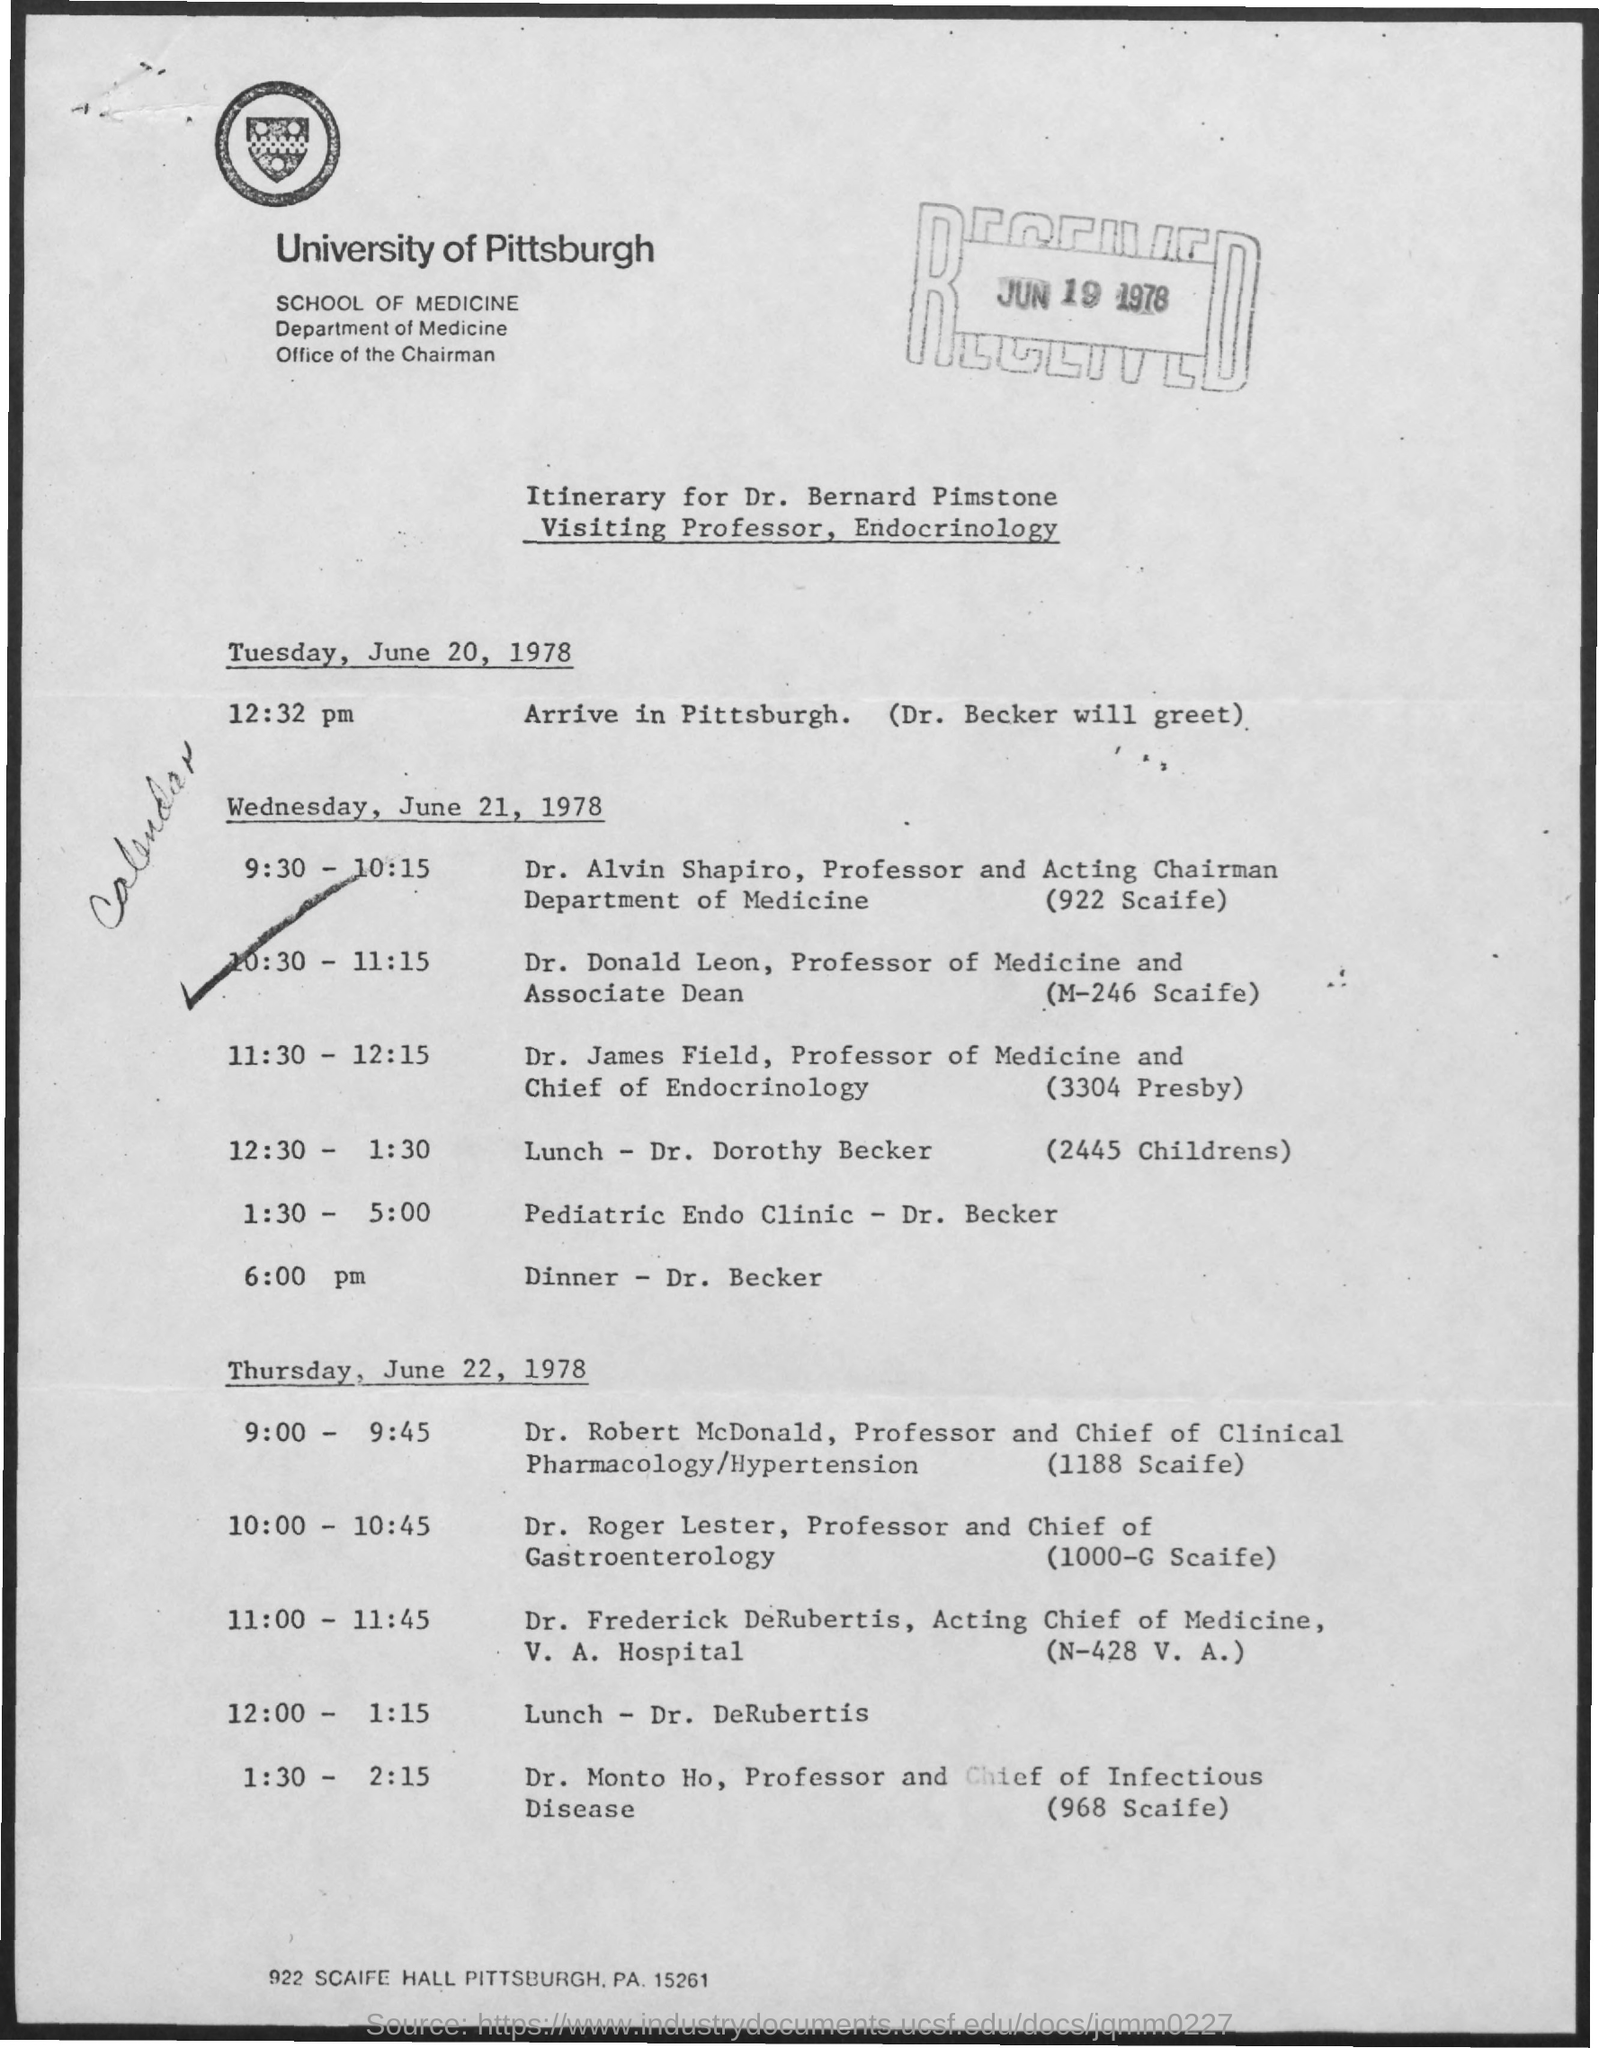Outline some significant characteristics in this image. The received date mentioned in the form is June 19, 1978. The University of Pittsburgh is named as the university mentioned in the text. 